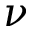Convert formula to latex. <formula><loc_0><loc_0><loc_500><loc_500>\nu</formula> 